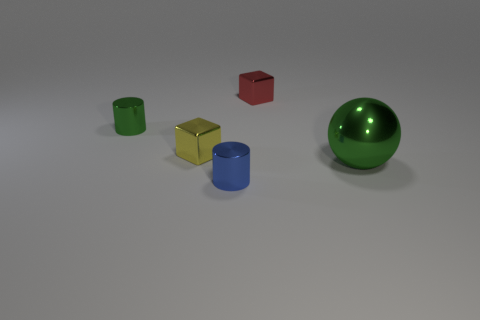Add 3 tiny shiny cylinders. How many objects exist? 8 Subtract all cylinders. How many objects are left? 3 Subtract all red spheres. Subtract all cyan blocks. How many spheres are left? 1 Subtract all balls. Subtract all tiny things. How many objects are left? 0 Add 2 small blocks. How many small blocks are left? 4 Add 1 small green metal cylinders. How many small green metal cylinders exist? 2 Subtract 0 purple blocks. How many objects are left? 5 